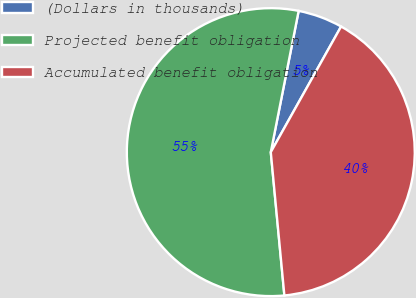<chart> <loc_0><loc_0><loc_500><loc_500><pie_chart><fcel>(Dollars in thousands)<fcel>Projected benefit obligation<fcel>Accumulated benefit obligation<nl><fcel>5.02%<fcel>54.6%<fcel>40.37%<nl></chart> 